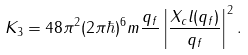Convert formula to latex. <formula><loc_0><loc_0><loc_500><loc_500>K _ { 3 } = 4 8 \pi ^ { 2 } ( 2 \pi \hbar { ) } ^ { 6 } m \frac { q _ { f } } { } \left | \frac { X _ { c } l ( q _ { f } ) } { q _ { f } } \right | ^ { 2 } .</formula> 